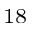Convert formula to latex. <formula><loc_0><loc_0><loc_500><loc_500>^ { 1 8 }</formula> 